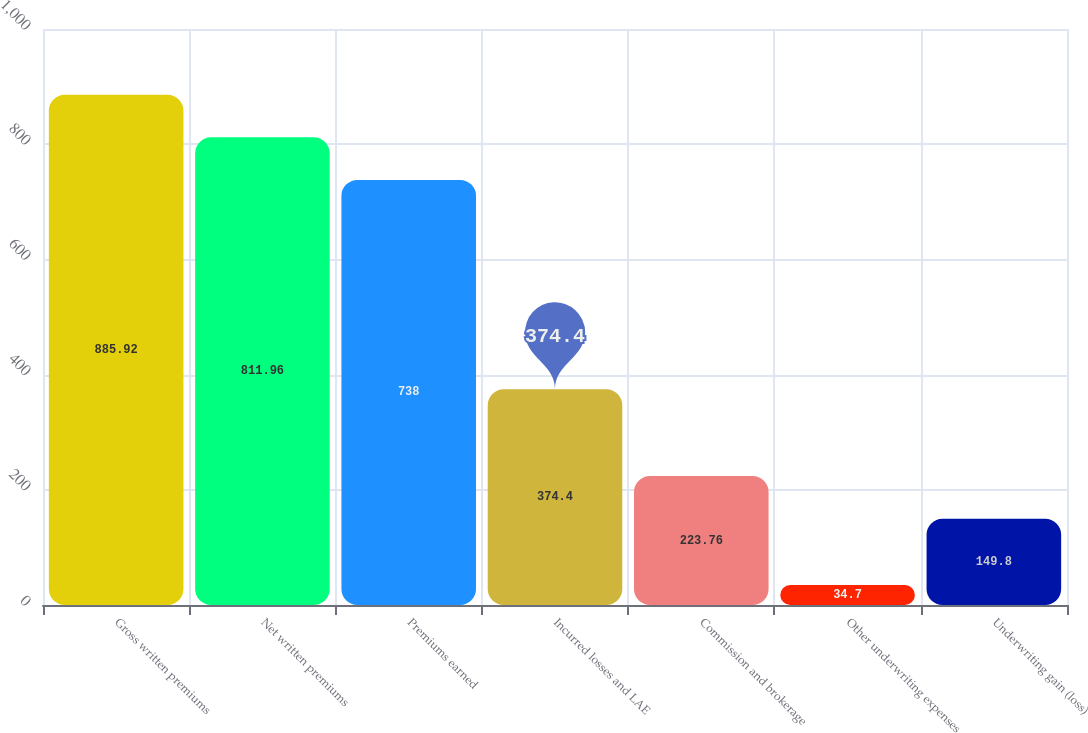<chart> <loc_0><loc_0><loc_500><loc_500><bar_chart><fcel>Gross written premiums<fcel>Net written premiums<fcel>Premiums earned<fcel>Incurred losses and LAE<fcel>Commission and brokerage<fcel>Other underwriting expenses<fcel>Underwriting gain (loss)<nl><fcel>885.92<fcel>811.96<fcel>738<fcel>374.4<fcel>223.76<fcel>34.7<fcel>149.8<nl></chart> 